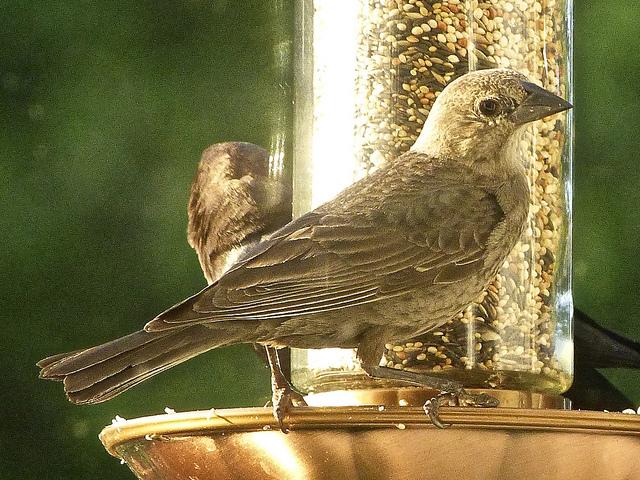Where is the bird photographed?
Give a very brief answer. Bird feeder. Where is the bird sitting?
Short answer required. Bird feeder. How many birds?
Be succinct. 2. What is the bird sitting on?
Be succinct. Bird feeder. What color is the bird?
Quick response, please. Brown. 